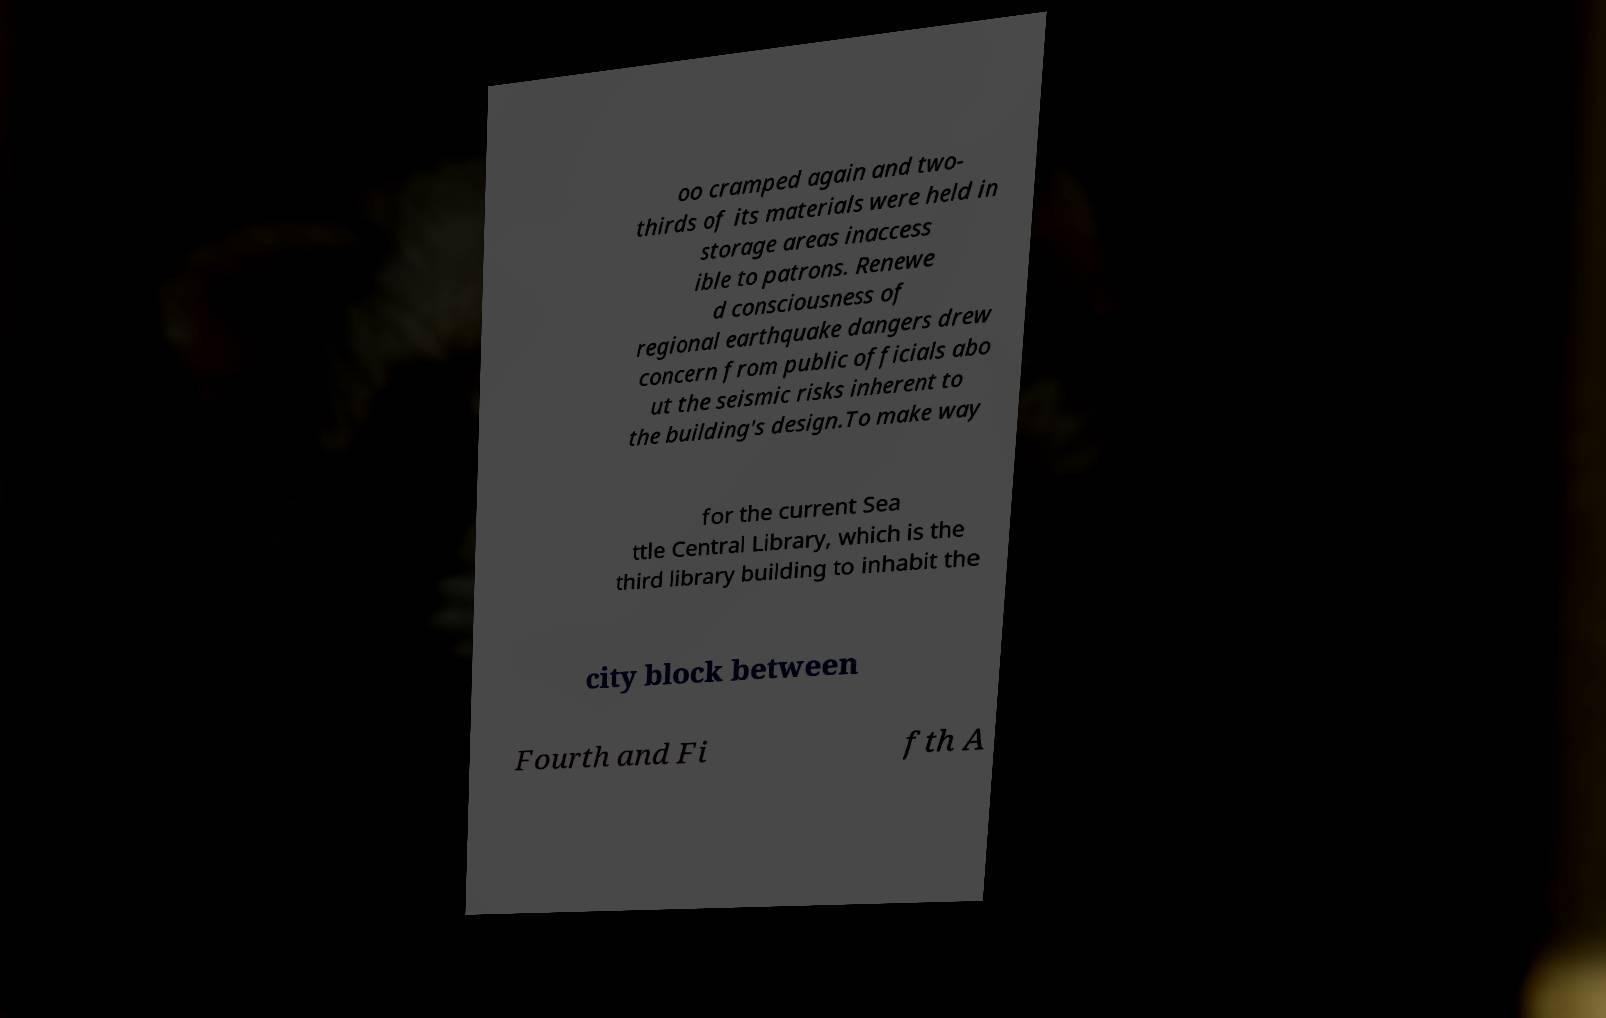Could you assist in decoding the text presented in this image and type it out clearly? oo cramped again and two- thirds of its materials were held in storage areas inaccess ible to patrons. Renewe d consciousness of regional earthquake dangers drew concern from public officials abo ut the seismic risks inherent to the building's design.To make way for the current Sea ttle Central Library, which is the third library building to inhabit the city block between Fourth and Fi fth A 